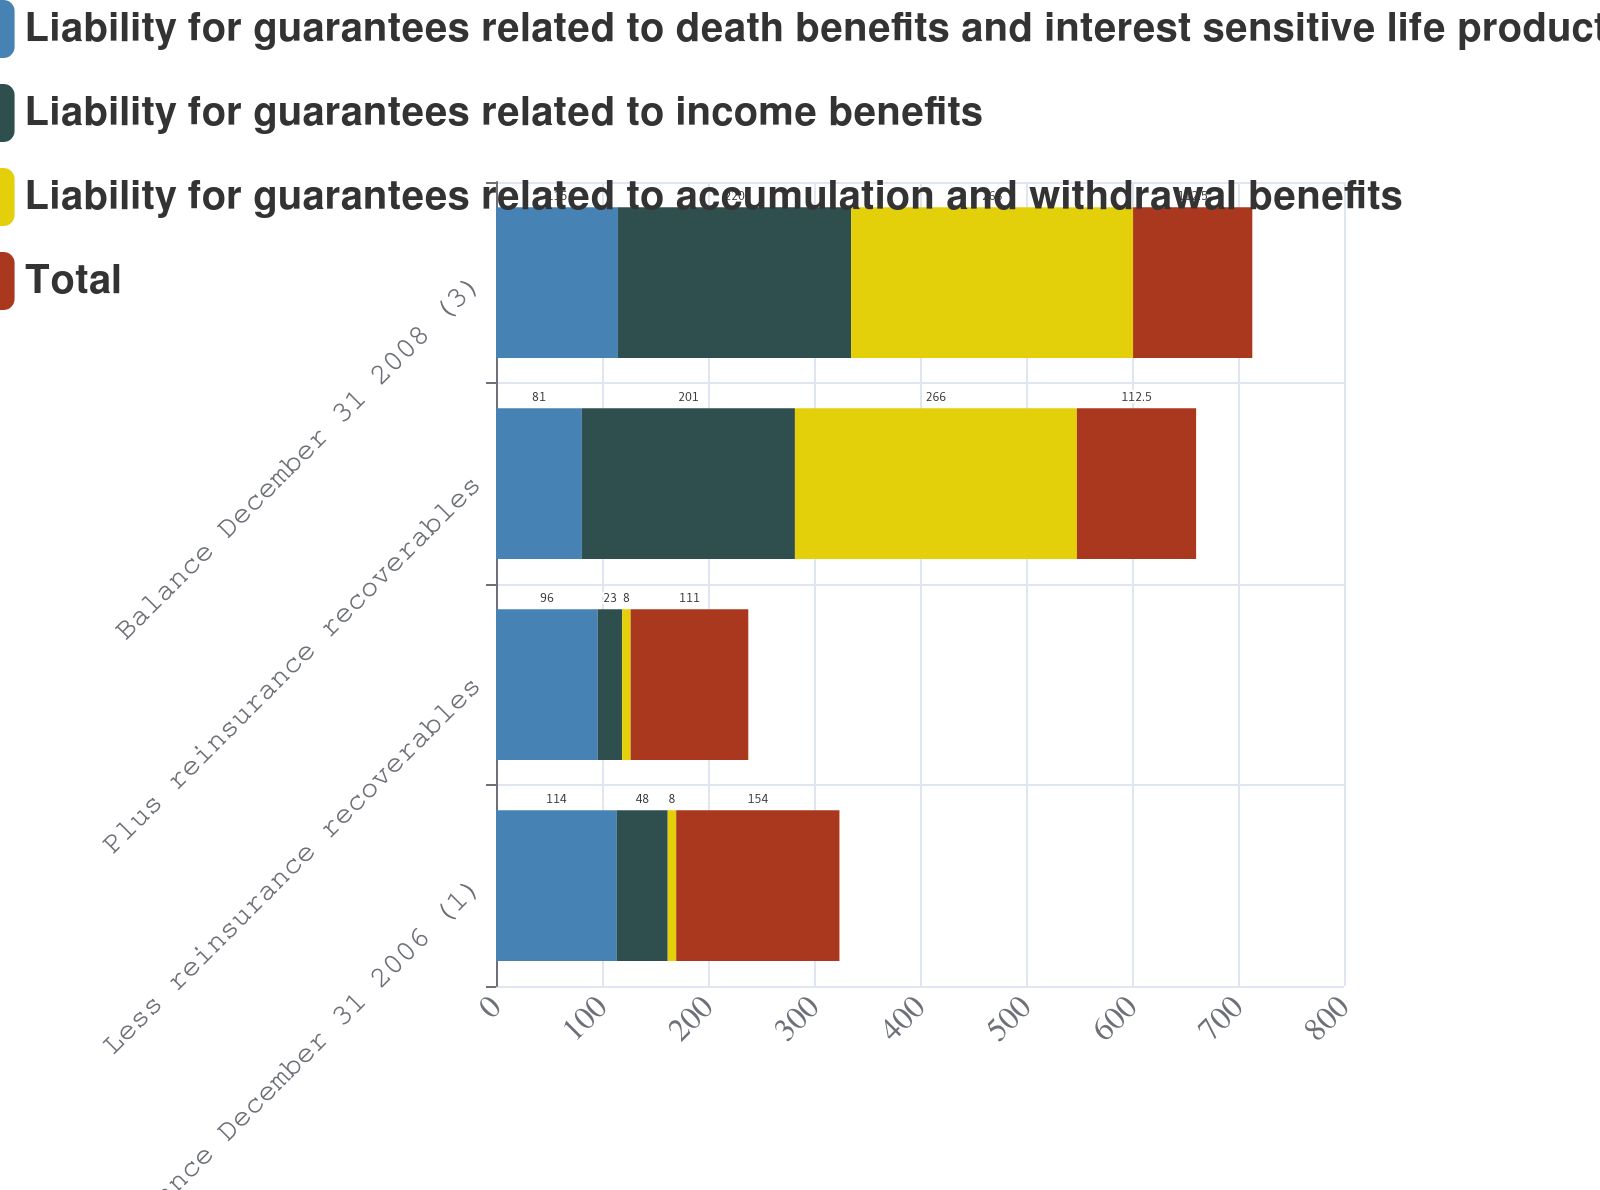<chart> <loc_0><loc_0><loc_500><loc_500><stacked_bar_chart><ecel><fcel>Balance December 31 2006 (1)<fcel>Less reinsurance recoverables<fcel>Plus reinsurance recoverables<fcel>Balance December 31 2008 (3)<nl><fcel>Liability for guarantees related to death benefits and interest sensitive life products<fcel>114<fcel>96<fcel>81<fcel>115<nl><fcel>Liability for guarantees related to income benefits<fcel>48<fcel>23<fcel>201<fcel>220<nl><fcel>Liability for guarantees related to accumulation and withdrawal benefits<fcel>8<fcel>8<fcel>266<fcel>266<nl><fcel>Total<fcel>154<fcel>111<fcel>112.5<fcel>112.5<nl></chart> 